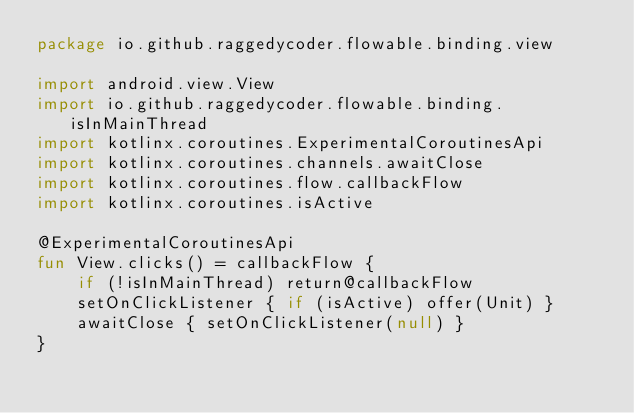Convert code to text. <code><loc_0><loc_0><loc_500><loc_500><_Kotlin_>package io.github.raggedycoder.flowable.binding.view

import android.view.View
import io.github.raggedycoder.flowable.binding.isInMainThread
import kotlinx.coroutines.ExperimentalCoroutinesApi
import kotlinx.coroutines.channels.awaitClose
import kotlinx.coroutines.flow.callbackFlow
import kotlinx.coroutines.isActive

@ExperimentalCoroutinesApi
fun View.clicks() = callbackFlow {
    if (!isInMainThread) return@callbackFlow
    setOnClickListener { if (isActive) offer(Unit) }
    awaitClose { setOnClickListener(null) }
}
</code> 